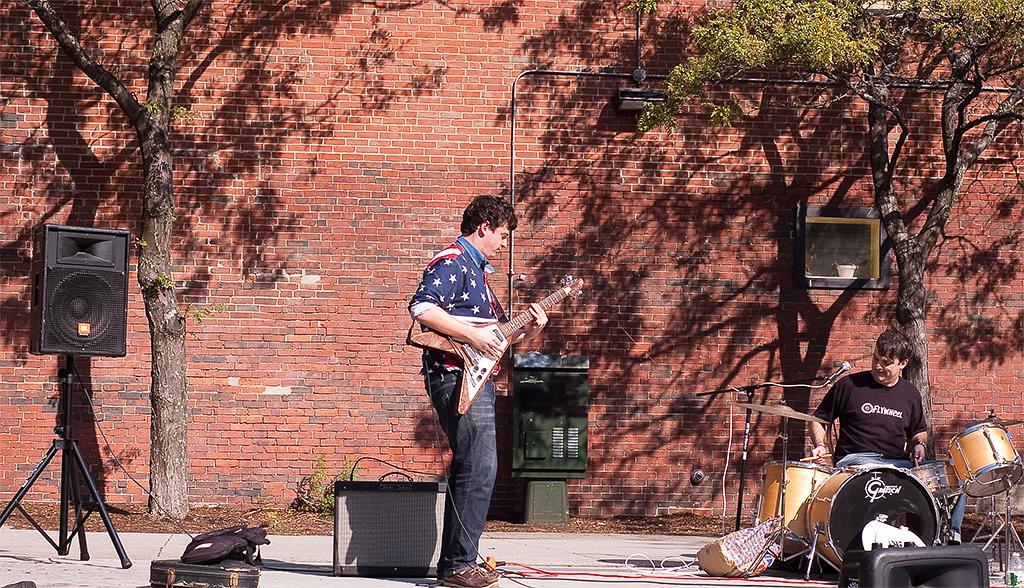Please provide a concise description of this image. In this picture there is a man standing and holding a guitar. There is also other man sitting and playing drum with a drum stick. There is a loudspeaker, tree ,wall, green object, bag, cup at the background. 